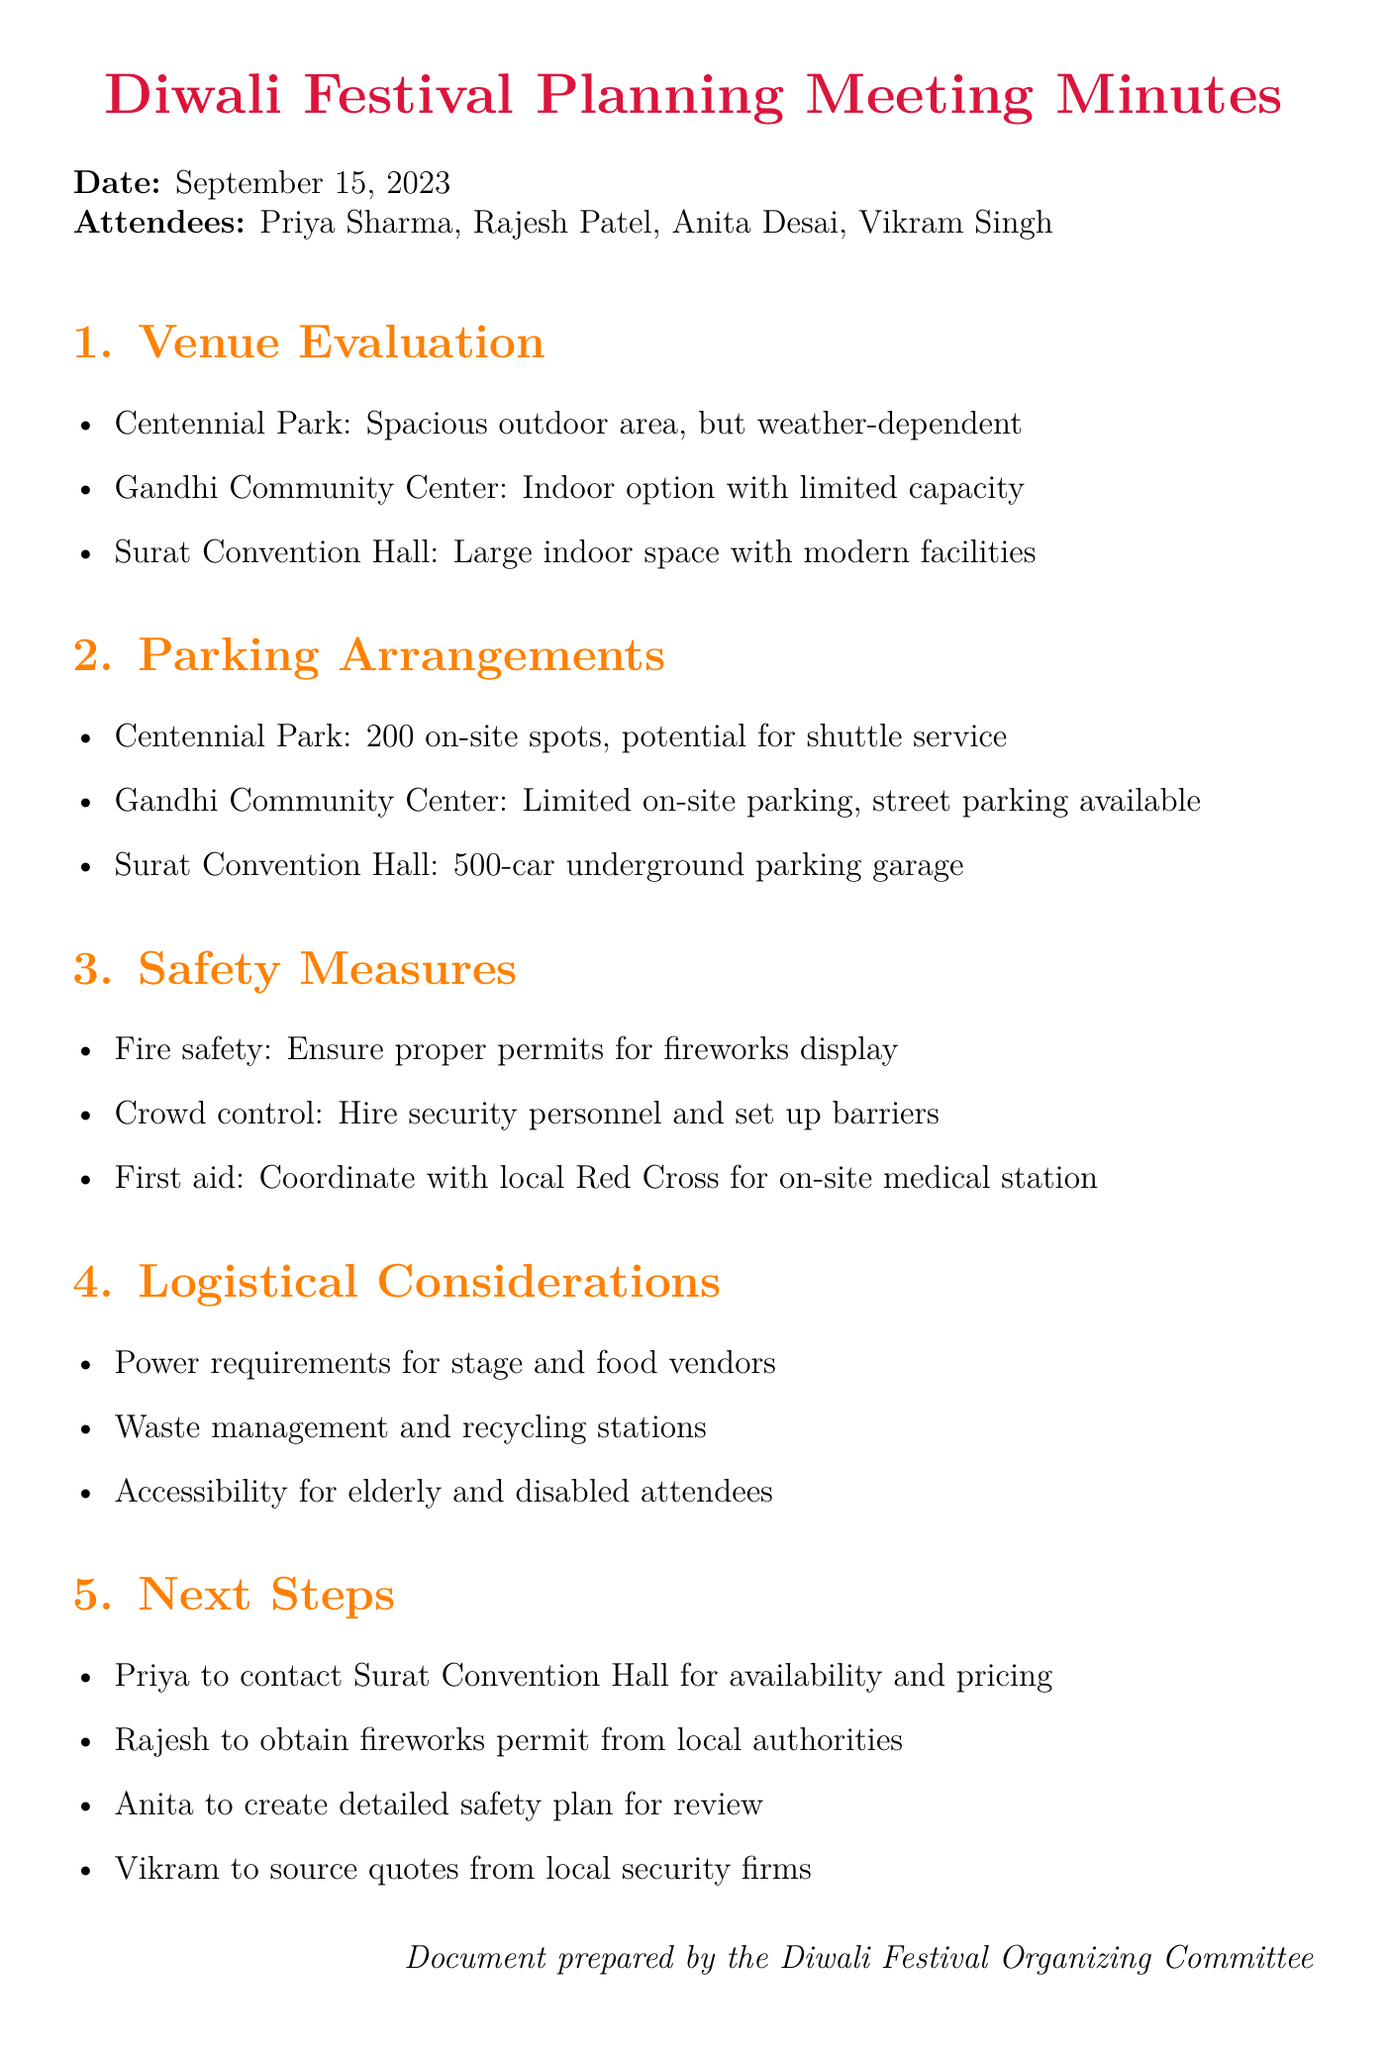What is the date of the meeting? The date of the meeting is specified at the beginning of the document as September 15, 2023.
Answer: September 15, 2023 Who is the event coordinator? The document lists the attendees, among which the event coordinator is Rajesh Patel.
Answer: Rajesh Patel How many on-site parking spots are available at Centennial Park? The discussion point for parking at Centennial Park mentions that there are 200 on-site spots available.
Answer: 200 Which venue has the largest indoor space? Comparing the venues, Surat Convention Hall is mentioned as having a large indoor space with modern facilities.
Answer: Surat Convention Hall What safety measure is coordinated with the local Red Cross? The document discusses safety measures, highlighting that coordination with the local Red Cross is for an on-site medical station.
Answer: On-site medical station What is one of the logistical considerations mentioned? The logistical considerations section has various points, one of which is the power requirements for stage and food vendors.
Answer: Power requirements for stage and food vendors What action item is assigned to Priya? The next steps section states that Priya is to contact Surat Convention Hall for availability and pricing.
Answer: Contact Surat Convention Hall for availability and pricing Which venue has limited on-site parking? Among the discussed venues, the Gandhi Community Center is noted to have limited on-site parking options.
Answer: Gandhi Community Center 